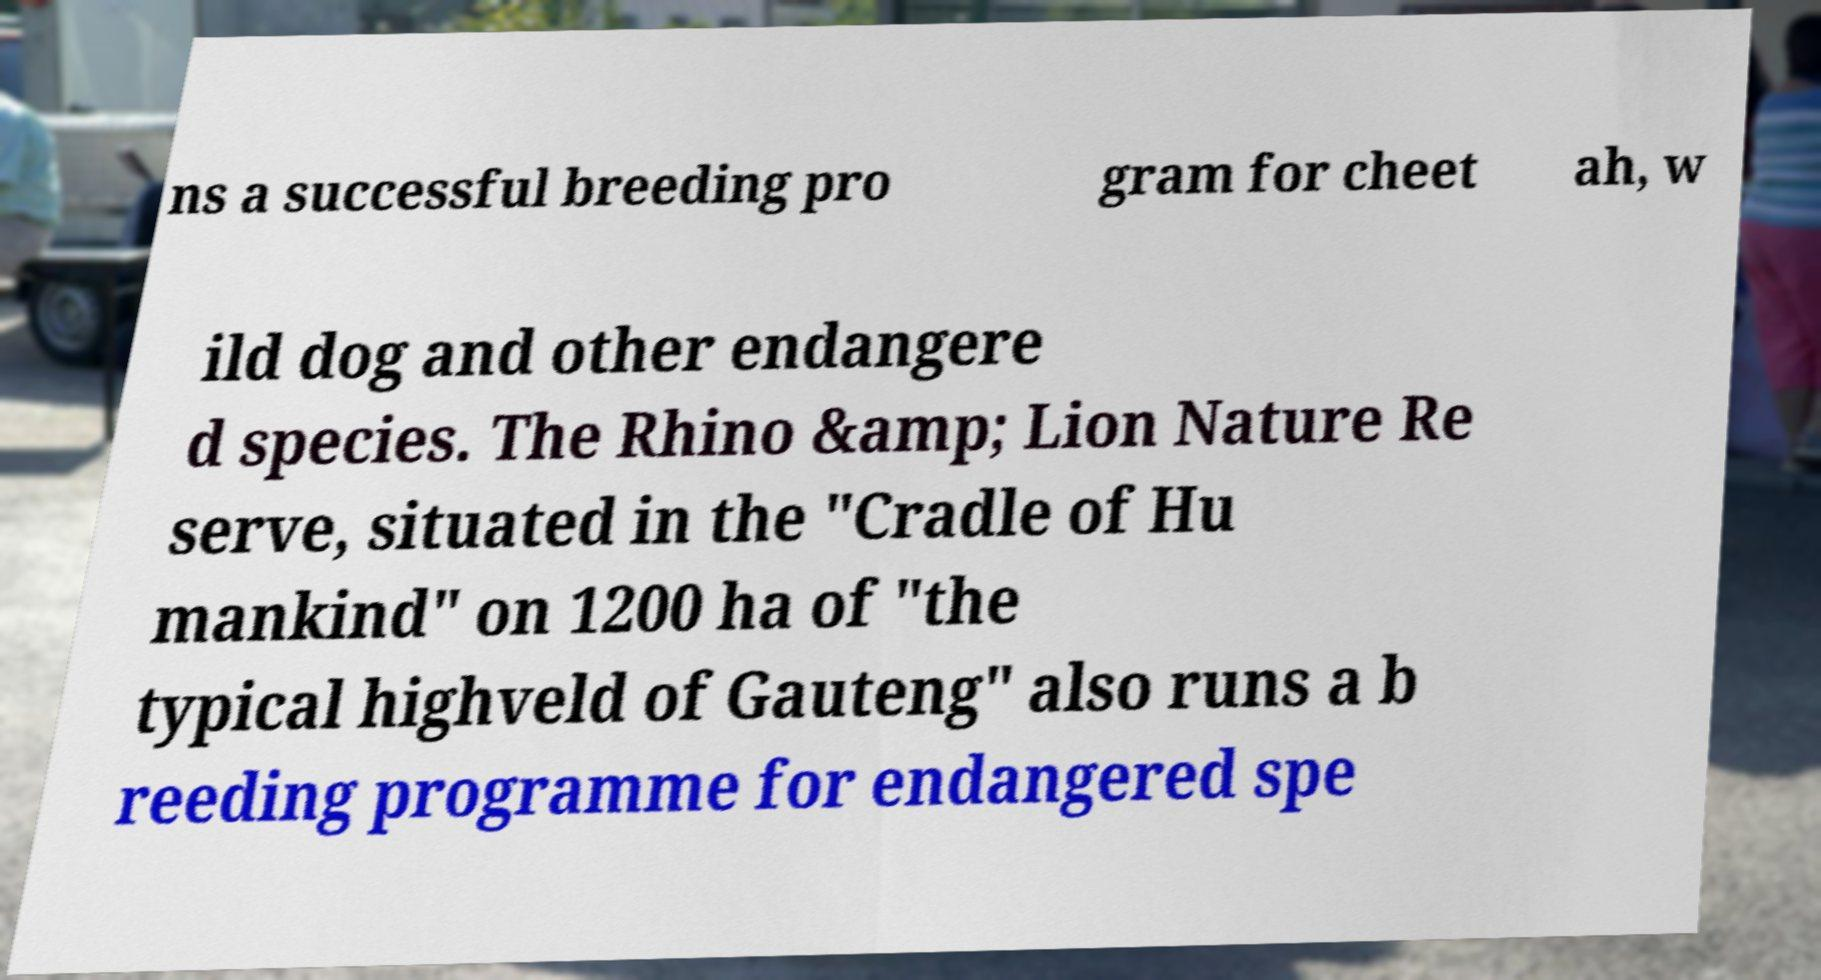Please identify and transcribe the text found in this image. ns a successful breeding pro gram for cheet ah, w ild dog and other endangere d species. The Rhino &amp; Lion Nature Re serve, situated in the "Cradle of Hu mankind" on 1200 ha of "the typical highveld of Gauteng" also runs a b reeding programme for endangered spe 